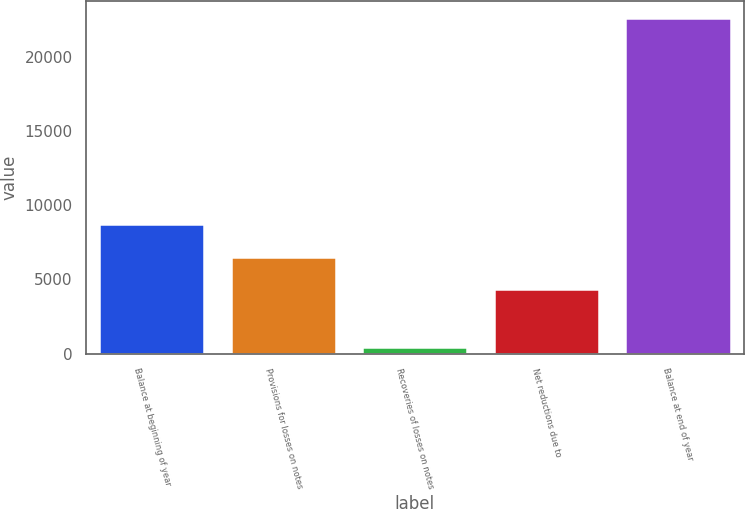<chart> <loc_0><loc_0><loc_500><loc_500><bar_chart><fcel>Balance at beginning of year<fcel>Provisions for losses on notes<fcel>Recoveries of losses on notes<fcel>Net reductions due to<fcel>Balance at end of year<nl><fcel>8764.4<fcel>6546.7<fcel>429<fcel>4329<fcel>22606<nl></chart> 